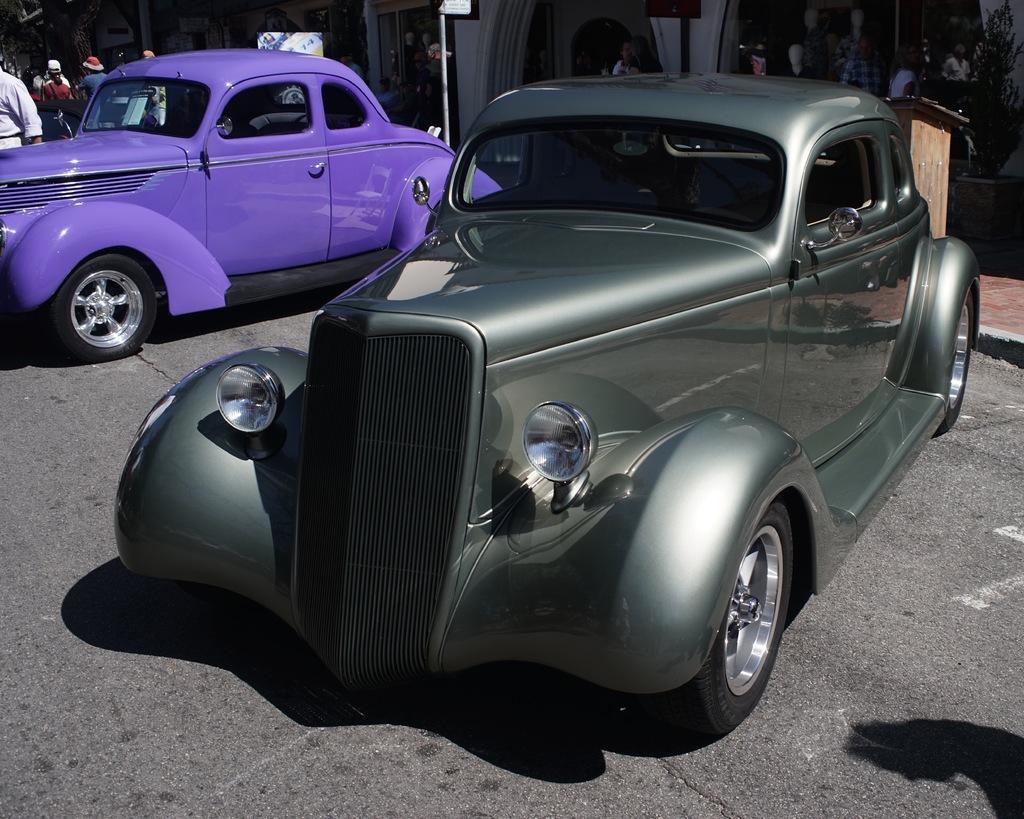Can you describe this image briefly? In this image there are two cars parked on the road and people are standing beside the cars. At the back side there are buildings. 